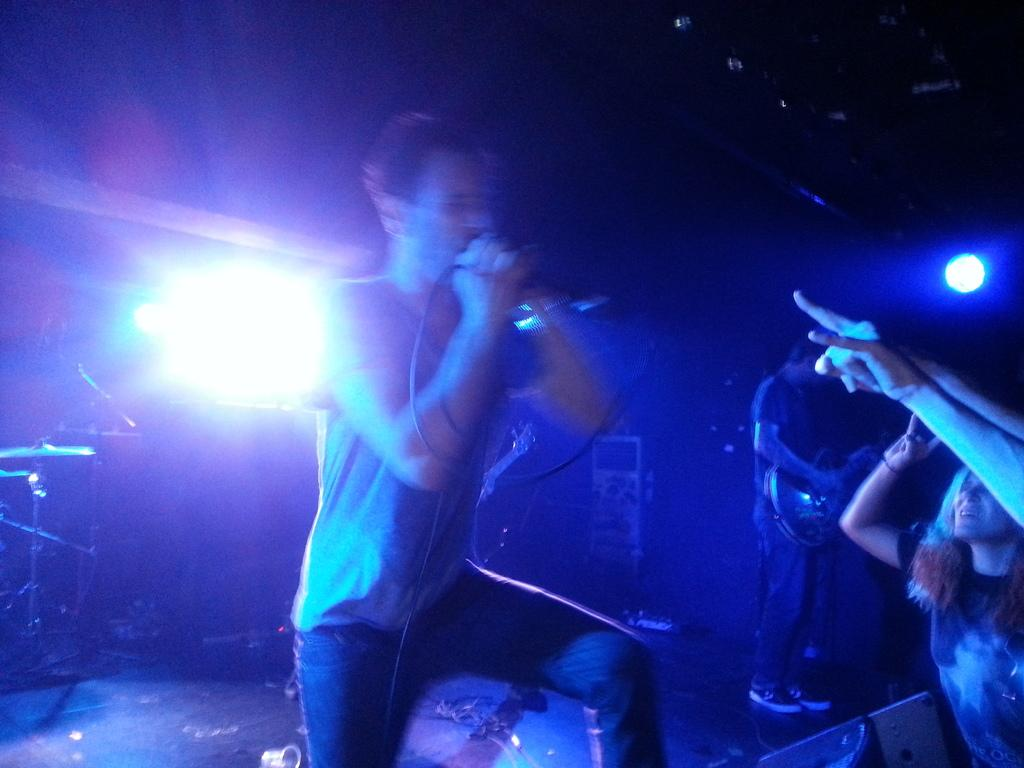How many people are in the image? There are people in the image, but the exact number is not specified. What is one person doing in the image? One person is holding a guitar. What can be seen in the background of the image? There are focusing lights and drum plates in the background. How would you describe the lighting in the image? The background is dark. What type of sack is being used to carry the stew in the image? There is no sack or stew present in the image. How many people are resting in the image? The number of people in the image is not specified, and there is no indication that anyone is resting. 